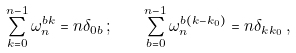<formula> <loc_0><loc_0><loc_500><loc_500>\sum _ { k = 0 } ^ { n - 1 } \omega _ { n } ^ { b k } = n \delta _ { 0 b } \, ; \quad \sum _ { b = 0 } ^ { n - 1 } \omega _ { n } ^ { b ( k - k _ { 0 } ) } = n \delta _ { k k _ { 0 } } \, ,</formula> 